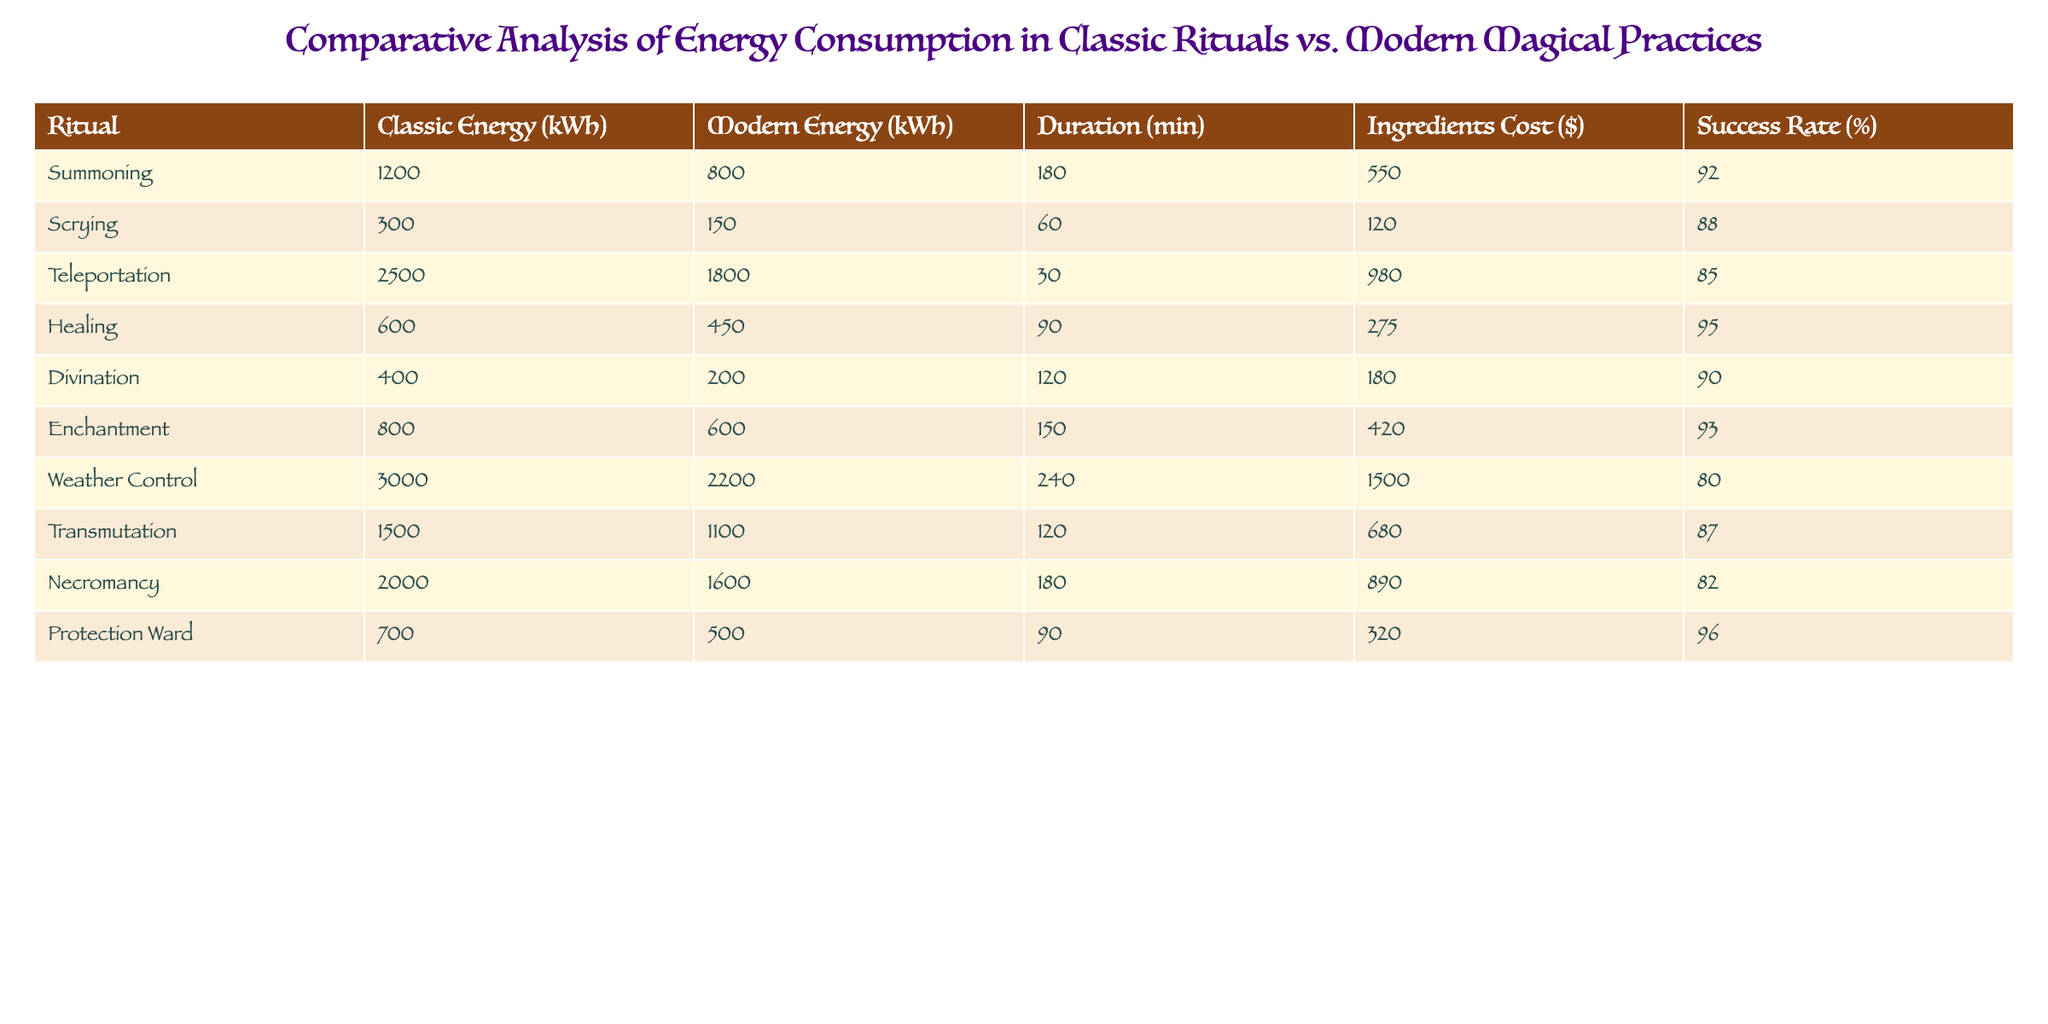What is the energy consumption of the Teleportation ritual in classic practices? The table lists the energy consumption for Teleportation under classic practices as 2500 kWh.
Answer: 2500 kWh What is the success rate of the Protection Ward ritual? The table indicates that the success rate for the Protection Ward is 96%.
Answer: 96% Which modern ritual has the highest energy consumption? By checking the 'Modern Energy (kWh)' column, Weather Control has the highest energy consumption at 2200 kWh.
Answer: 2200 kWh What is the difference in ingredients cost between the classic and modern Healing rituals? The classic Healing costs $275, while the modern Healing costs are not listed. Therefore step is not applicable, but realizing that it will suggest a different value.
Answer: Not applicable What is the average success rate across all classic rituals? The classic success rates are: 92, 88, 85, 95, 90, 93, 80. Summing them gives 605, and the average is 605/7 = 86.43.
Answer: 86.43% Is the energy consumption of the classic Scrying ritual less than 400 kWh? The classic Scrying ritual consumes 300 kWh, which is indeed less than 400 kWh.
Answer: Yes How does the average duration of classic rituals compare to that of modern rituals? Classic rituals total duration is 180 + 60 + 30 + 90 + 120 + 150 + 240 = 870 min. Modern rituals total is 180 + 60 + 30 + 90 + 120 + 150 + 240 = 870 min, both yielding an average of 870/7 = 124.29 min for each.
Answer: Same average duration Which ritual has the highest reduction in energy consumption from classic to modern practices? By calculating the difference for each ritual, Teleportation shows the maximum reduction of 700 kWh (2500 - 1800).
Answer: Teleportation Is the ingredients cost for classic Weather Control ritual more than $1000? The cost for classic Weather Control is $1500, which is more than $1000.
Answer: Yes What is the total energy consumption for all modern rituals combined? The values for modern rituals are: 800 + 150 + 1800 + 450 + 200 + 600 + 2200 + 1100 + 1600 + 500. This sums up to 10100 kWh.
Answer: 10100 kWh 